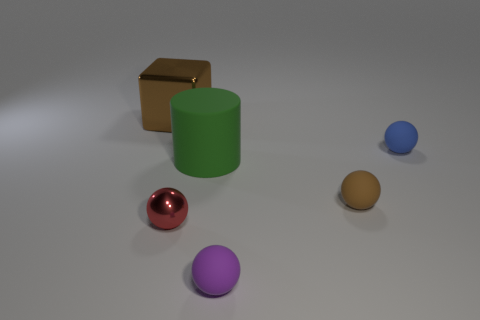Add 4 small red balls. How many objects exist? 10 Subtract all spheres. How many objects are left? 2 Subtract 0 blue cubes. How many objects are left? 6 Subtract all purple metallic cylinders. Subtract all shiny things. How many objects are left? 4 Add 3 metallic cubes. How many metallic cubes are left? 4 Add 4 tiny blue things. How many tiny blue things exist? 5 